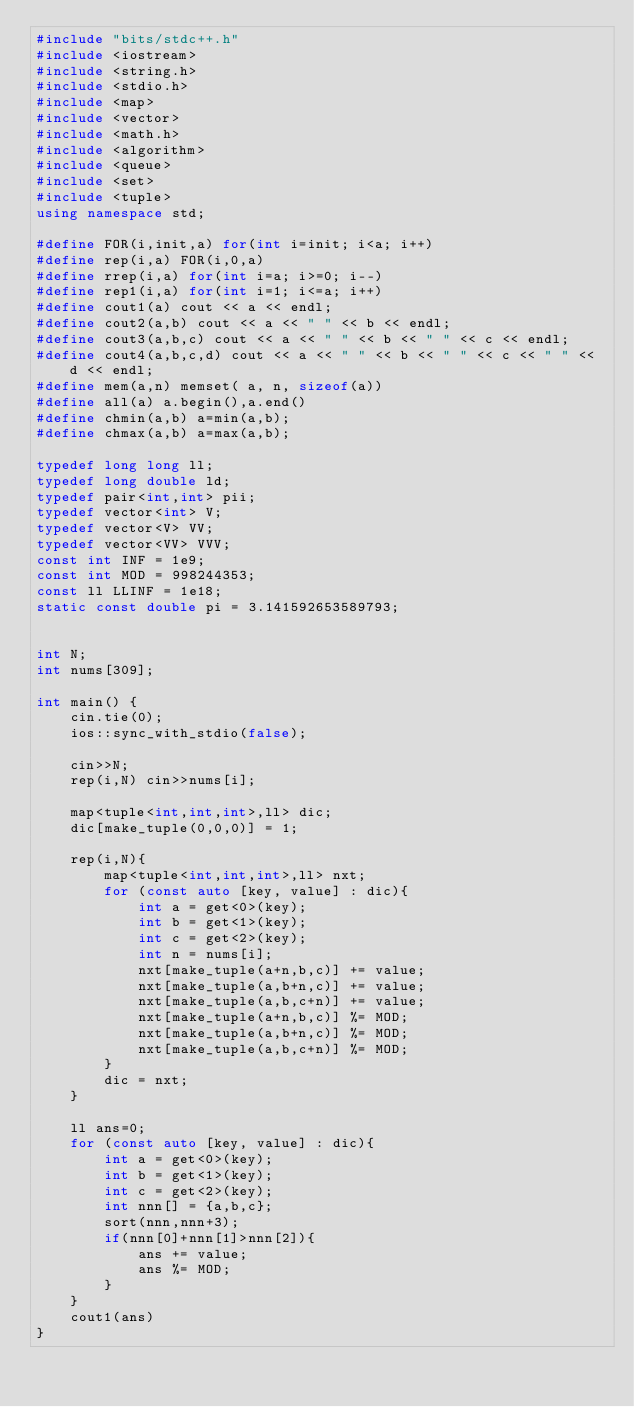Convert code to text. <code><loc_0><loc_0><loc_500><loc_500><_C++_>#include "bits/stdc++.h"
#include <iostream>
#include <string.h>
#include <stdio.h>
#include <map>
#include <vector>
#include <math.h>
#include <algorithm>
#include <queue>
#include <set>
#include <tuple>
using namespace std;

#define FOR(i,init,a) for(int i=init; i<a; i++)
#define rep(i,a) FOR(i,0,a)
#define rrep(i,a) for(int i=a; i>=0; i--)
#define rep1(i,a) for(int i=1; i<=a; i++)
#define cout1(a) cout << a << endl;
#define cout2(a,b) cout << a << " " << b << endl;
#define cout3(a,b,c) cout << a << " " << b << " " << c << endl;
#define cout4(a,b,c,d) cout << a << " " << b << " " << c << " " << d << endl;
#define mem(a,n) memset( a, n, sizeof(a))
#define all(a) a.begin(),a.end()
#define chmin(a,b) a=min(a,b);
#define chmax(a,b) a=max(a,b);

typedef long long ll;
typedef long double ld;
typedef pair<int,int> pii;
typedef vector<int> V;
typedef vector<V> VV;
typedef vector<VV> VVV;
const int INF = 1e9;
const int MOD = 998244353;
const ll LLINF = 1e18;
static const double pi = 3.141592653589793;


int N;
int nums[309];

int main() {
    cin.tie(0);
    ios::sync_with_stdio(false);
    
    cin>>N;
    rep(i,N) cin>>nums[i];
    
    map<tuple<int,int,int>,ll> dic;
    dic[make_tuple(0,0,0)] = 1;
    
    rep(i,N){
        map<tuple<int,int,int>,ll> nxt;
        for (const auto [key, value] : dic){
            int a = get<0>(key);
            int b = get<1>(key);
            int c = get<2>(key);
            int n = nums[i];
            nxt[make_tuple(a+n,b,c)] += value;
            nxt[make_tuple(a,b+n,c)] += value;
            nxt[make_tuple(a,b,c+n)] += value;
            nxt[make_tuple(a+n,b,c)] %= MOD;
            nxt[make_tuple(a,b+n,c)] %= MOD;
            nxt[make_tuple(a,b,c+n)] %= MOD;
        }
        dic = nxt;
    }
    
    ll ans=0;
    for (const auto [key, value] : dic){
        int a = get<0>(key);
        int b = get<1>(key);
        int c = get<2>(key);
        int nnn[] = {a,b,c};
        sort(nnn,nnn+3);
        if(nnn[0]+nnn[1]>nnn[2]){
            ans += value;
            ans %= MOD;
        }
    }
    cout1(ans)
}</code> 